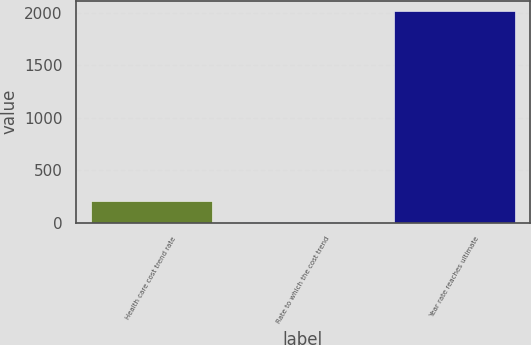Convert chart to OTSL. <chart><loc_0><loc_0><loc_500><loc_500><bar_chart><fcel>Health care cost trend rate<fcel>Rate to which the cost trend<fcel>Year rate reaches ultimate<nl><fcel>205.7<fcel>5<fcel>2012<nl></chart> 